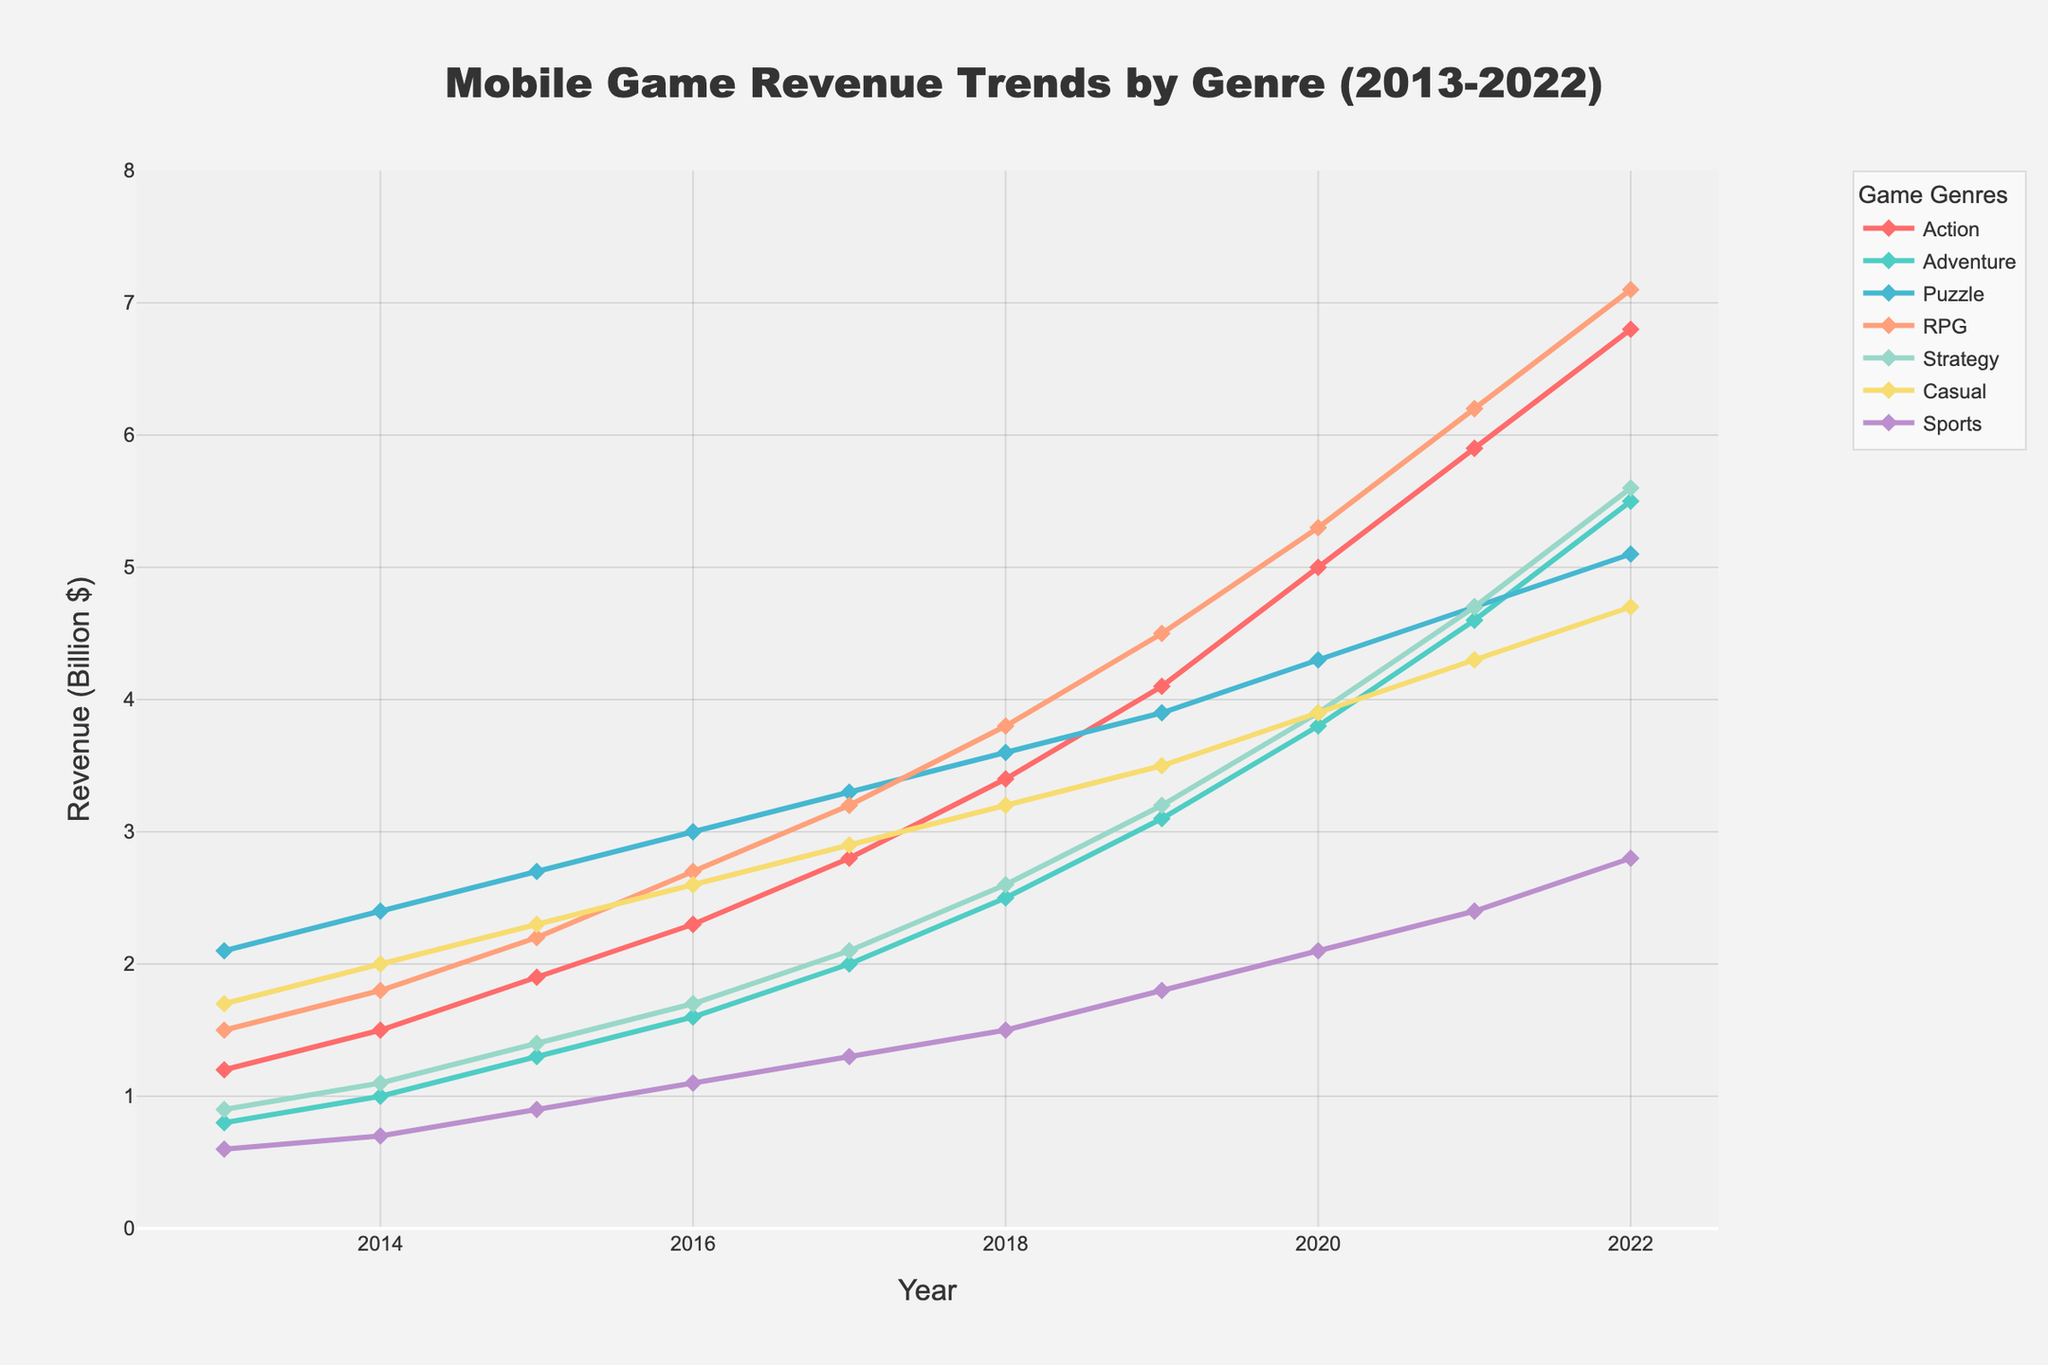What is the total revenue generated by the Puzzle genre from 2013 to 2022? Sum the revenue values for the Puzzle genre from each year: 2.1 + 2.4 + 2.7 + 3.0 + 3.3 + 3.6 + 3.9 + 4.3 + 4.7 + 5.1
Answer: 35.1 Which genre experienced the highest revenue growth between 2013 and 2022? Calculate the difference in revenue between 2022 and 2013 for each genre. The genre with the highest difference is the one with the highest growth. Action: 6.8-1.2 = 5.6, Adventure: 5.5-0.8 = 4.7, Puzzle: 5.1-2.1 = 3.0, RPG: 7.1-1.5 = 5.6, Strategy: 5.6-0.9 = 4.7, Casual: 4.7-1.7 = 3.0, Sports: 2.8-0.6 = 2.2. Both Action and RPG have the highest growth
Answer: Action and RPG In which year did the RPG genre surpass the $4 billion revenue mark? From the figure, trace the RPG revenue line and identify the year when it first exceeds $4 billion. RPG surpasses $4 billion in 2019
Answer: 2019 Which two genres had the closest revenue figures in 2020 and what were those figures? Compare the revenue values of each genre in 2020 to find the closest two: Action: 5.0, Adventure: 3.8, Puzzle: 4.3, RPG: 5.3, Strategy: 3.9, Casual: 3.9, Sports: 2.1. Puzzle and RPG are closest at 4.3 and 3.9, with a difference of 0.4
Answer: Puzzle and Strategy Which genre had a consistent yearly increase in revenue over the decade? Observe each genre’s trend to see if there is a line with no downward slope points. Action, Adventure, Puzzle, RPG, Strategy, Casual, and Sports all show consistent yearly increases
Answer: Action, Adventure, Puzzle, RPG, Strategy, Casual, Sports Between which two consecutive years did the Casual genre see the highest increase in revenue? Calculate the annual increase in revenue for Casual between each consecutive year: 2013-2014: 2.0-1.7=0.3, 2014-2015: 2.3-2.0=0.3, 2015-2016: 2.6-2.3=0.3, 2016-2017: 2.9-2.6=0.3, 2017-2018: 3.2-2.9=0.3, 2018-2019: 3.5-3.2=0.3, 2019-2020: 3.9-3.5=0.4, 2020-2021: 4.3-3.9=0.4, 2021-2022: 4.7-4.3=0.4. The highest increase of 0.4 is seen in 2019-2020, 2020-2021, 2021-2022
Answer: 2019-2020, 2020-2021, 2021-2022 What is the average annual revenue for the Action genre over the decade? Sum the revenues for the Action genre and divide by the number of years: (1.2+1.5+1.9+2.3+2.8+3.4+4.1+5.0+5.9+6.8)/10 = 35.9/10
Answer: 3.59 What color represents the Sports genre in the chart? From the figure, observe the color associated with the Sports line and markers. It is purple
Answer: Purple 